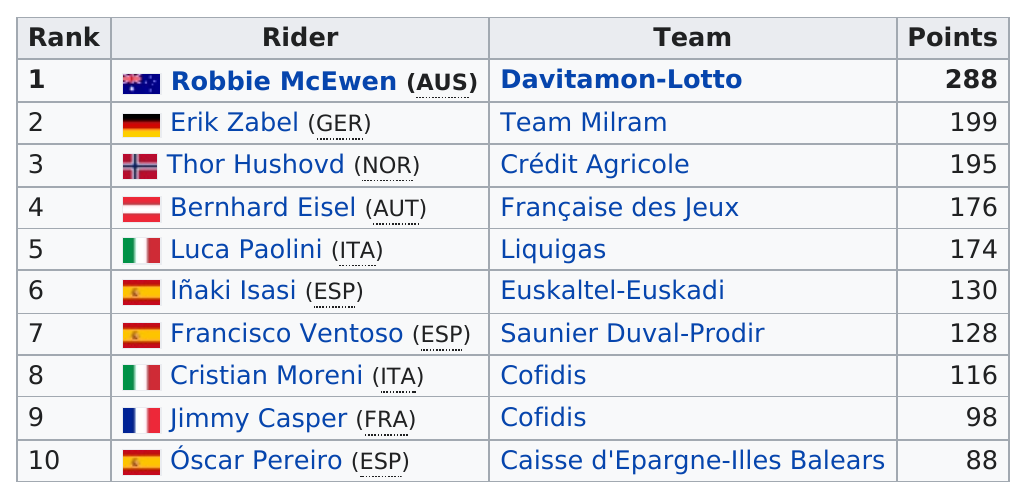Highlight a few significant elements in this photo. Robbie McEwen and Cristian Moreni scored a total of 404 points together during their careers as professional cyclists. Erik Zabel outscored Francisco Ventoso by 71 points. 